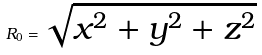<formula> <loc_0><loc_0><loc_500><loc_500>R _ { 0 } = \sqrt { x ^ { 2 } + y ^ { 2 } + z ^ { 2 } }</formula> 